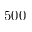Convert formula to latex. <formula><loc_0><loc_0><loc_500><loc_500>5 0 0</formula> 